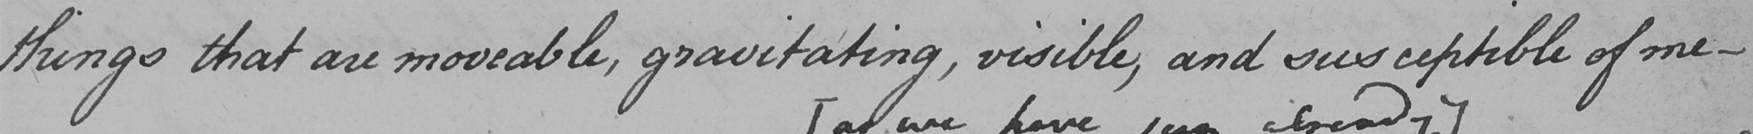Can you read and transcribe this handwriting? things that are moveable , gravitating , visible , and susceptible of me- 